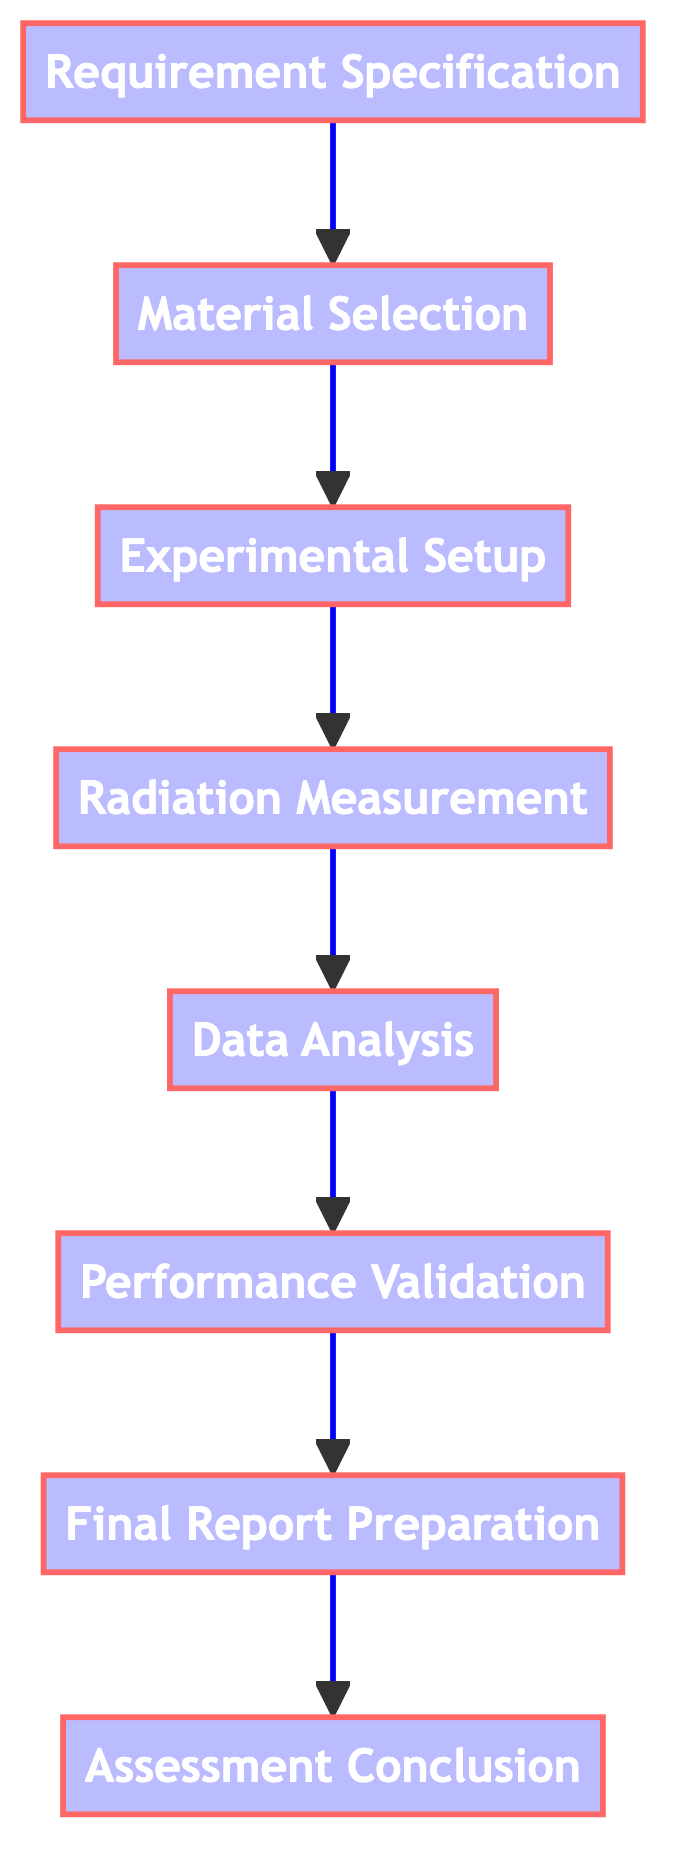What is the first step in the process? The first step in the process is Requirement Specification, as it is the bottom node in the flowchart indicating it leads to the subsequent steps.
Answer: Requirement Specification How many total steps are there in the process? There are eight nodes present in the flowchart representing the steps, each connected sequentially, indicating a total of eight steps.
Answer: Eight Which step comes immediately after Radiation Measurement? The step that comes immediately after Radiation Measurement is Data Analysis, as indicated by the upward connection in the flowchart.
Answer: Data Analysis What is the final outcome of the process? The final outcome of the process, as depicted in the topmost node of the flowchart, is Assessment Conclusion.
Answer: Assessment Conclusion Which two steps are connected directly? The steps that are connected directly are Performance Validation and Final Report Preparation, as there is a direct link from Performance Validation to Final Report Preparation.
Answer: Performance Validation and Final Report Preparation What is the relationship between Material Selection and Requirement Specification? Material Selection follows Requirement Specification, indicating that it is dependent on the completion of Requirement Specification for the next step to occur.
Answer: Sequential dependency What type of analysis is performed before validating performance? Data Analysis is performed before validating performance, indicated by the placement and connection in the upward flow of the diagram.
Answer: Data Analysis What materials might be considered during Material Selection? Materials such as lead, concrete, or polyethylene might be considered during Material Selection, as stated in the description of that node.
Answer: Lead, concrete, or polyethylene What action is taken after Performance Validation? After Performance Validation, the action taken is Final Report Preparation, which is the next step in the flow of the process.
Answer: Final Report Preparation 